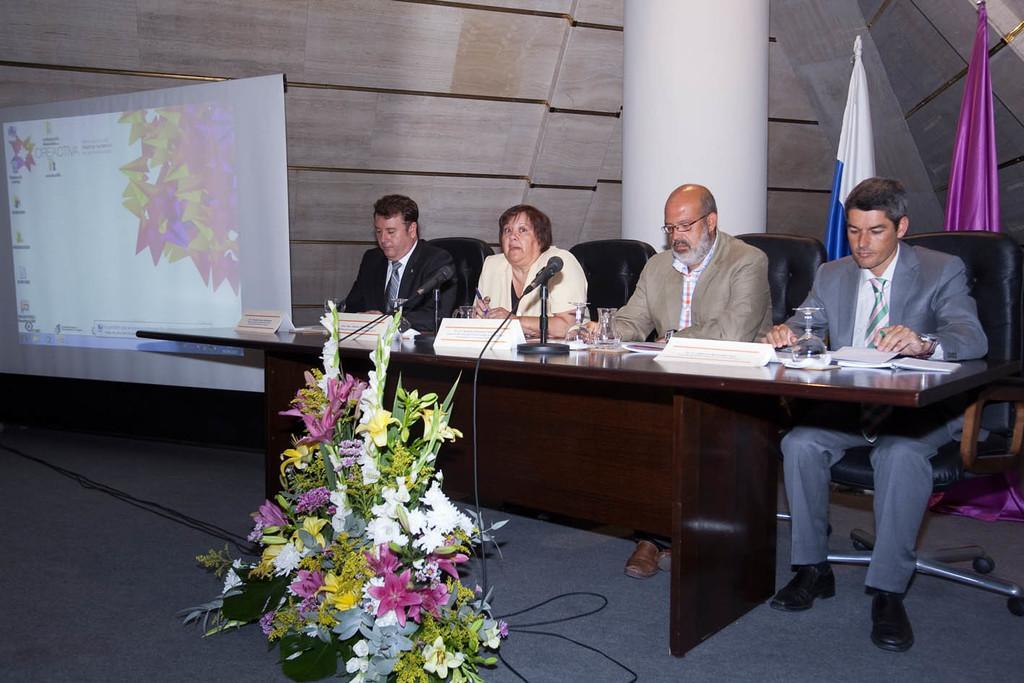In one or two sentences, can you explain what this image depicts? In this image I can see people sitting on the chairs. This is a table. On this table I can see a glass,name boards,mike with mike stand some papers on it. This is the flower bouquet placed on the flower with the beautiful flowers. This is a screen which is hanged. I can see a pillar at the background which is white in color. At the right corner of the image I can see two flags one is violet in color and the other one is white and blue in color. This woman is wearing cream colored suit. 